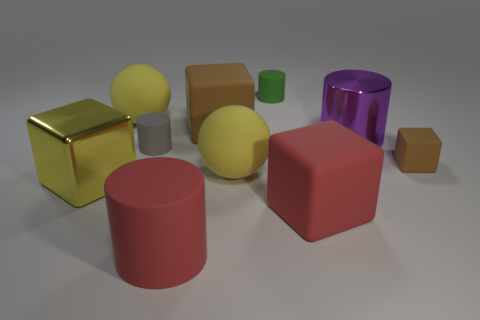Are there any gray matte cylinders? yes 